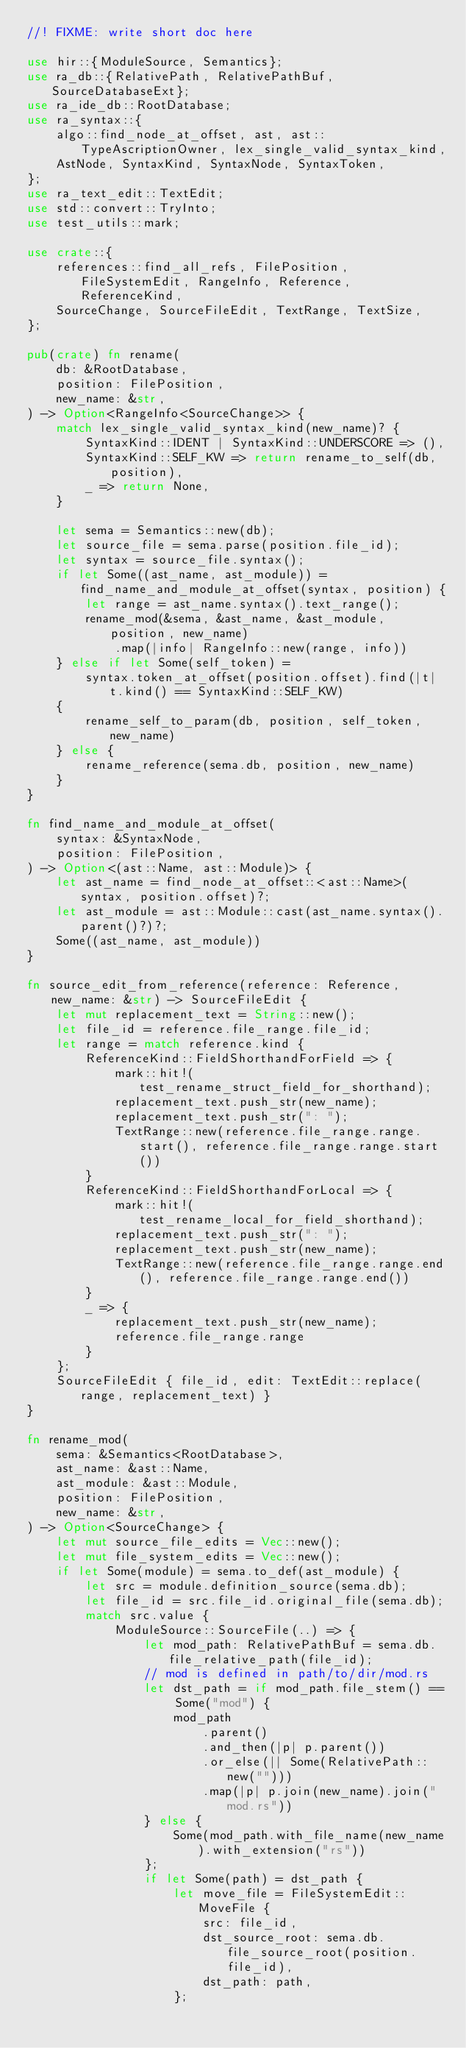Convert code to text. <code><loc_0><loc_0><loc_500><loc_500><_Rust_>//! FIXME: write short doc here

use hir::{ModuleSource, Semantics};
use ra_db::{RelativePath, RelativePathBuf, SourceDatabaseExt};
use ra_ide_db::RootDatabase;
use ra_syntax::{
    algo::find_node_at_offset, ast, ast::TypeAscriptionOwner, lex_single_valid_syntax_kind,
    AstNode, SyntaxKind, SyntaxNode, SyntaxToken,
};
use ra_text_edit::TextEdit;
use std::convert::TryInto;
use test_utils::mark;

use crate::{
    references::find_all_refs, FilePosition, FileSystemEdit, RangeInfo, Reference, ReferenceKind,
    SourceChange, SourceFileEdit, TextRange, TextSize,
};

pub(crate) fn rename(
    db: &RootDatabase,
    position: FilePosition,
    new_name: &str,
) -> Option<RangeInfo<SourceChange>> {
    match lex_single_valid_syntax_kind(new_name)? {
        SyntaxKind::IDENT | SyntaxKind::UNDERSCORE => (),
        SyntaxKind::SELF_KW => return rename_to_self(db, position),
        _ => return None,
    }

    let sema = Semantics::new(db);
    let source_file = sema.parse(position.file_id);
    let syntax = source_file.syntax();
    if let Some((ast_name, ast_module)) = find_name_and_module_at_offset(syntax, position) {
        let range = ast_name.syntax().text_range();
        rename_mod(&sema, &ast_name, &ast_module, position, new_name)
            .map(|info| RangeInfo::new(range, info))
    } else if let Some(self_token) =
        syntax.token_at_offset(position.offset).find(|t| t.kind() == SyntaxKind::SELF_KW)
    {
        rename_self_to_param(db, position, self_token, new_name)
    } else {
        rename_reference(sema.db, position, new_name)
    }
}

fn find_name_and_module_at_offset(
    syntax: &SyntaxNode,
    position: FilePosition,
) -> Option<(ast::Name, ast::Module)> {
    let ast_name = find_node_at_offset::<ast::Name>(syntax, position.offset)?;
    let ast_module = ast::Module::cast(ast_name.syntax().parent()?)?;
    Some((ast_name, ast_module))
}

fn source_edit_from_reference(reference: Reference, new_name: &str) -> SourceFileEdit {
    let mut replacement_text = String::new();
    let file_id = reference.file_range.file_id;
    let range = match reference.kind {
        ReferenceKind::FieldShorthandForField => {
            mark::hit!(test_rename_struct_field_for_shorthand);
            replacement_text.push_str(new_name);
            replacement_text.push_str(": ");
            TextRange::new(reference.file_range.range.start(), reference.file_range.range.start())
        }
        ReferenceKind::FieldShorthandForLocal => {
            mark::hit!(test_rename_local_for_field_shorthand);
            replacement_text.push_str(": ");
            replacement_text.push_str(new_name);
            TextRange::new(reference.file_range.range.end(), reference.file_range.range.end())
        }
        _ => {
            replacement_text.push_str(new_name);
            reference.file_range.range
        }
    };
    SourceFileEdit { file_id, edit: TextEdit::replace(range, replacement_text) }
}

fn rename_mod(
    sema: &Semantics<RootDatabase>,
    ast_name: &ast::Name,
    ast_module: &ast::Module,
    position: FilePosition,
    new_name: &str,
) -> Option<SourceChange> {
    let mut source_file_edits = Vec::new();
    let mut file_system_edits = Vec::new();
    if let Some(module) = sema.to_def(ast_module) {
        let src = module.definition_source(sema.db);
        let file_id = src.file_id.original_file(sema.db);
        match src.value {
            ModuleSource::SourceFile(..) => {
                let mod_path: RelativePathBuf = sema.db.file_relative_path(file_id);
                // mod is defined in path/to/dir/mod.rs
                let dst_path = if mod_path.file_stem() == Some("mod") {
                    mod_path
                        .parent()
                        .and_then(|p| p.parent())
                        .or_else(|| Some(RelativePath::new("")))
                        .map(|p| p.join(new_name).join("mod.rs"))
                } else {
                    Some(mod_path.with_file_name(new_name).with_extension("rs"))
                };
                if let Some(path) = dst_path {
                    let move_file = FileSystemEdit::MoveFile {
                        src: file_id,
                        dst_source_root: sema.db.file_source_root(position.file_id),
                        dst_path: path,
                    };</code> 